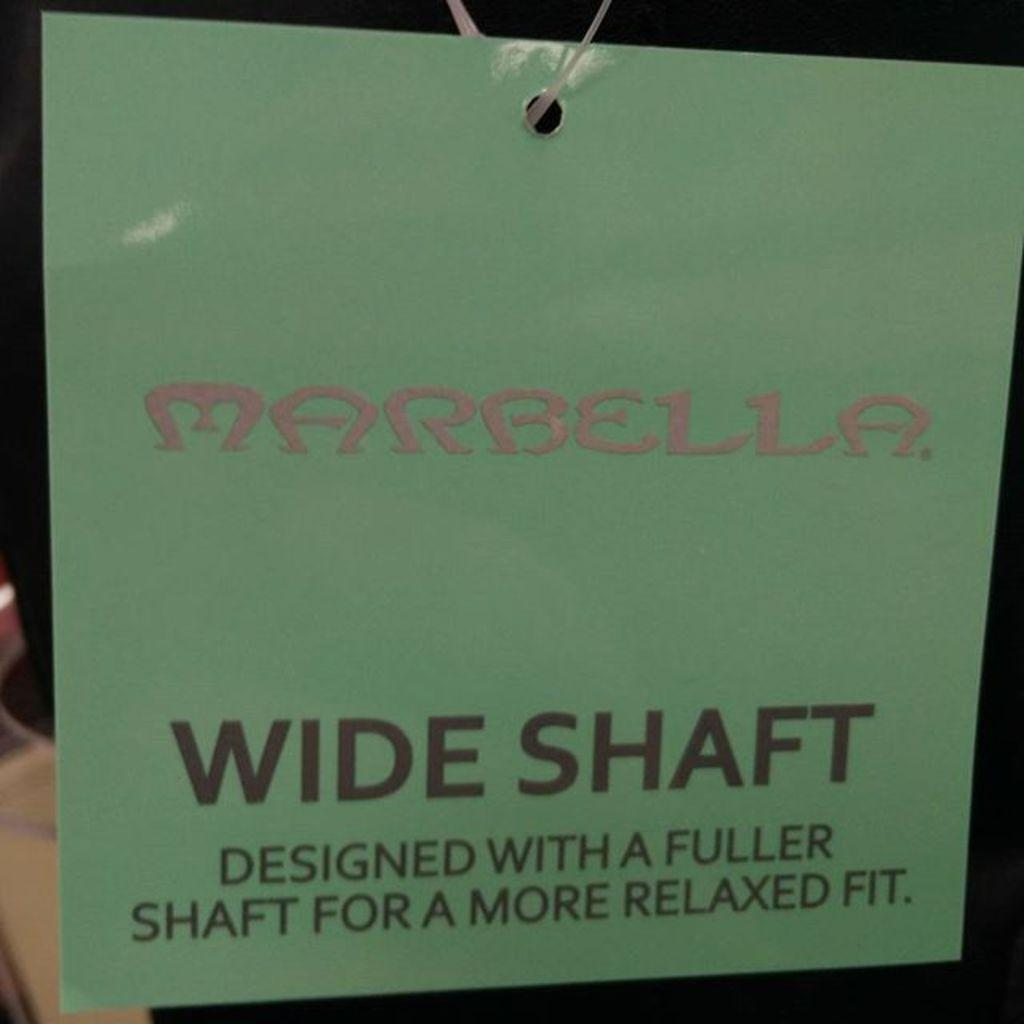Provide a one-sentence caption for the provided image. Hanging green sign that says "Marbella" in pink. 